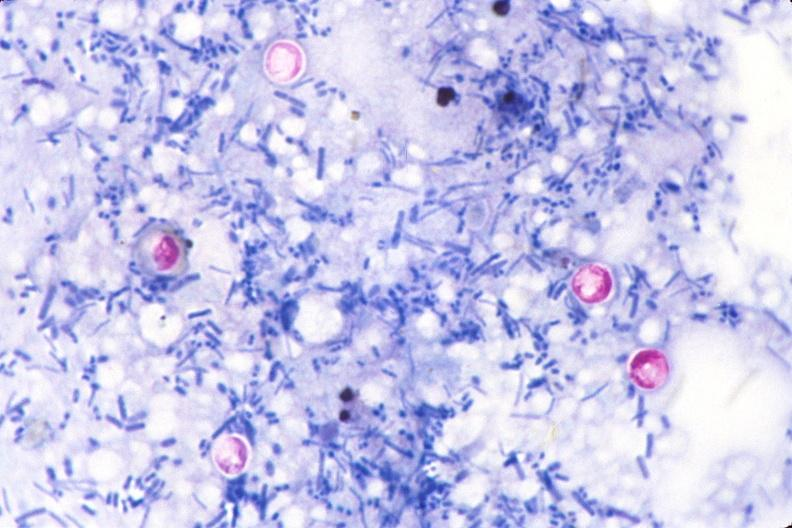does cachexia stain of feces?
Answer the question using a single word or phrase. No 